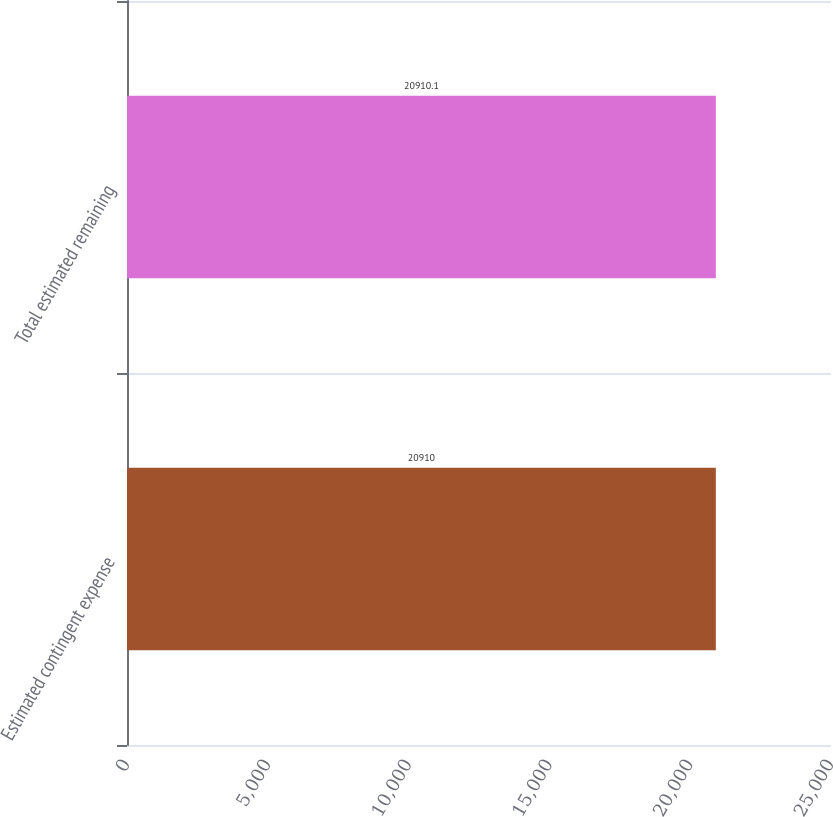Convert chart to OTSL. <chart><loc_0><loc_0><loc_500><loc_500><bar_chart><fcel>Estimated contingent expense<fcel>Total estimated remaining<nl><fcel>20910<fcel>20910.1<nl></chart> 